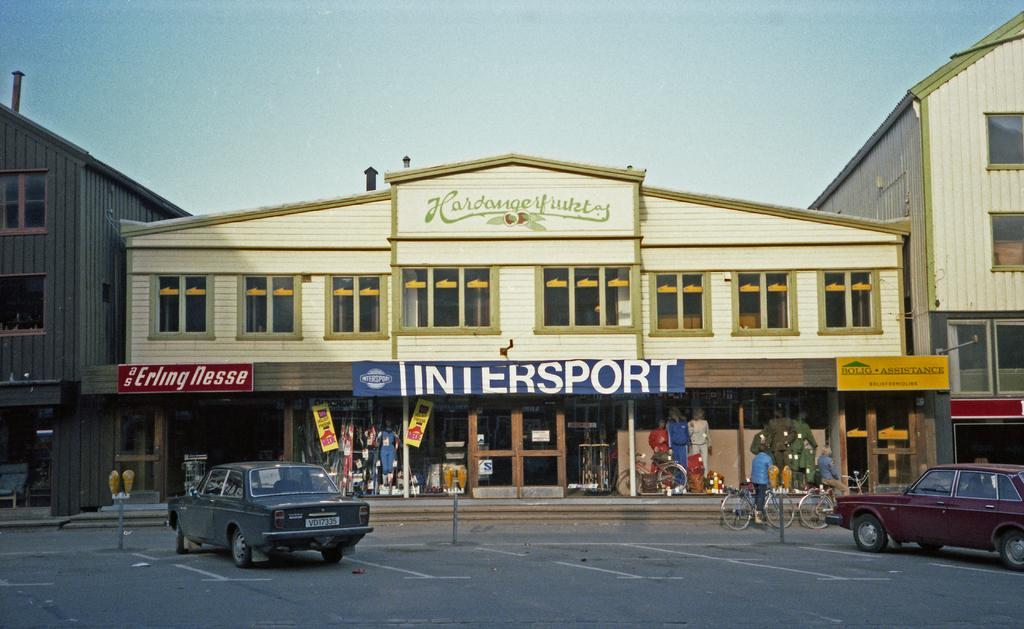What is located at the center of the image? There are buildings and stalls at the center of the image. What can be seen in front of the buildings and stalls? There are vehicles in front of the buildings and stalls. What mode of transportation is present on the road? Bicycles are on the road. What is visible in the background of the image? There is a sky visible in the background of the image. What type of curve is present in the middle of the image? There is no curve present in the middle of the image; it features buildings, stalls, and vehicles. What list can be seen hanging on the wall of the buildings? There is no list visible in the image; it only shows buildings, stalls, vehicles, and bicycles. 